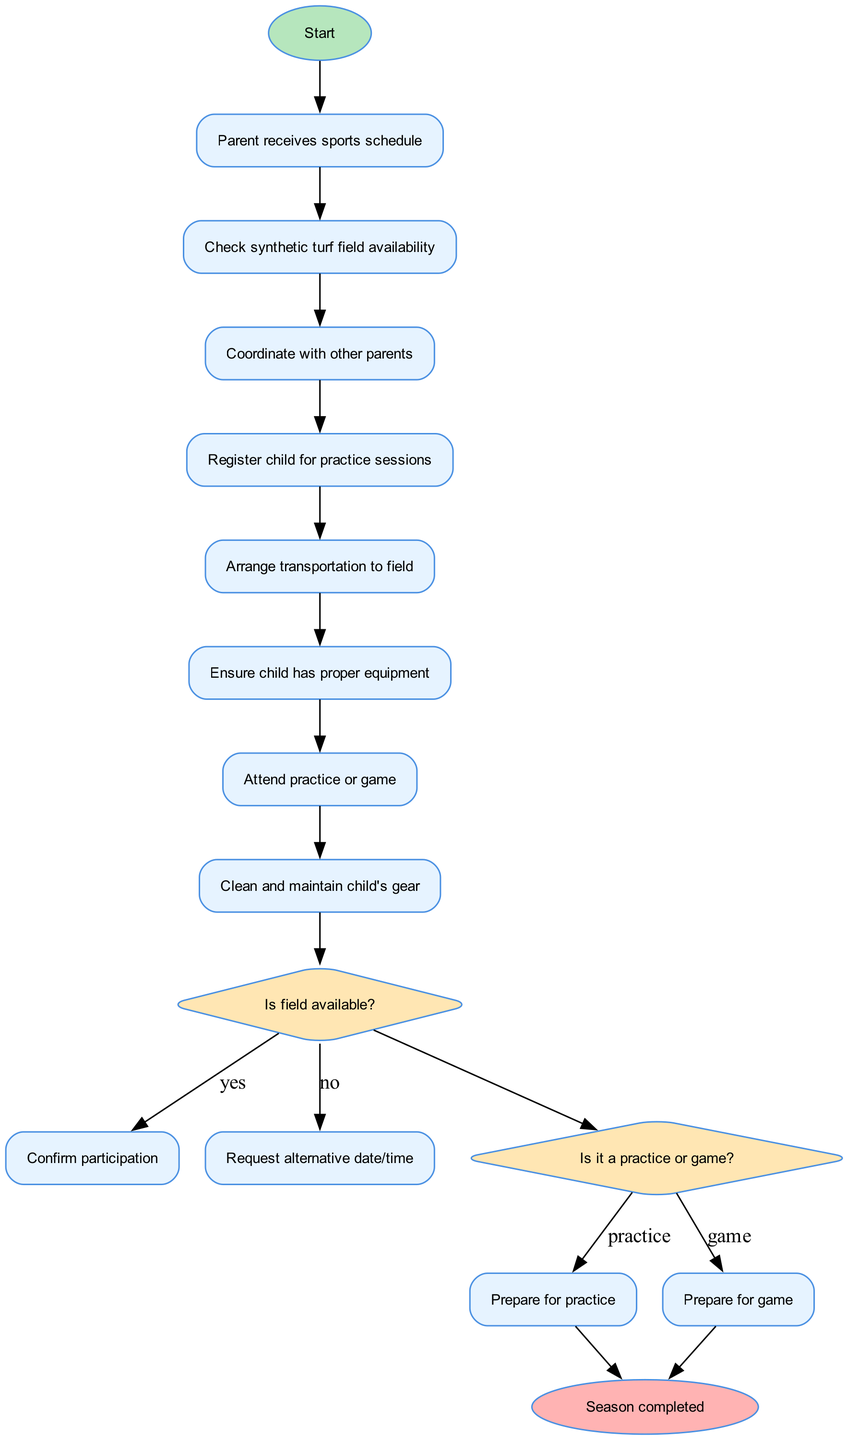What is the starting activity in the diagram? The diagram begins with the activity labeled "Parent receives sports schedule," which is the first action taken in the process.
Answer: Parent receives sports schedule How many activities are listed in the diagram? The diagram presents a total of 7 activities. This can be counted by reviewing the list of activities provided in the data.
Answer: 7 What decision must be made after the last activity? After the last activity "Attend practice or game," the question posed is "Is field available?" which dictates the next steps based on the field's availability.
Answer: Is field available? What are the two outcomes of the decision "Is field available?" The outcomes for the decision "Is field available?" are "Confirm participation" if yes and "Request alternative date/time" if no. Both outcomes are directly linked to this decision node.
Answer: Confirm participation, Request alternative date/time What is the last activity before reaching the end node? The last activity before the end node is "Clean and maintain child's gear." This is the final task before concluding the season.
Answer: Clean and maintain child's gear What action is taken if it is a game? If it is determined to be a game, the action taken is to "Prepare for game" as per the decision made following the field availability verification.
Answer: Prepare for game What shape represents decisions in the diagram? Decisions in the diagram are represented by diamond shapes, which is a standard convention in activity diagrams to indicate points where a choice needs to be made.
Answer: Diamond How does the diagram flow from practice to decision? If it is determined to be a practice, the flow continues to "Prepare for practice" as the action that follows the decision regarding the type of activity. This connects the nodes logically based on prior decisions.
Answer: Prepare for practice 